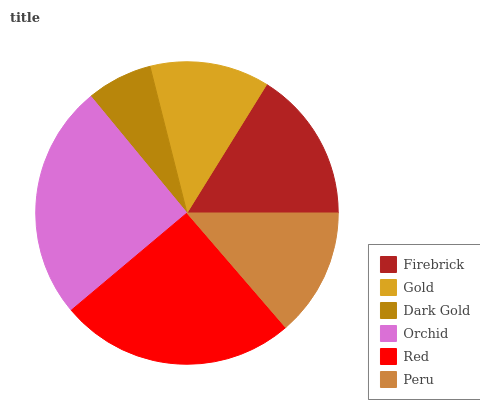Is Dark Gold the minimum?
Answer yes or no. Yes. Is Red the maximum?
Answer yes or no. Yes. Is Gold the minimum?
Answer yes or no. No. Is Gold the maximum?
Answer yes or no. No. Is Firebrick greater than Gold?
Answer yes or no. Yes. Is Gold less than Firebrick?
Answer yes or no. Yes. Is Gold greater than Firebrick?
Answer yes or no. No. Is Firebrick less than Gold?
Answer yes or no. No. Is Firebrick the high median?
Answer yes or no. Yes. Is Peru the low median?
Answer yes or no. Yes. Is Gold the high median?
Answer yes or no. No. Is Red the low median?
Answer yes or no. No. 